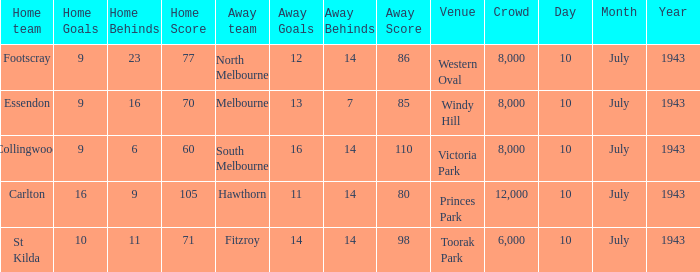When the Away team scored 14.14 (98), which Venue did the game take place? Toorak Park. Would you be able to parse every entry in this table? {'header': ['Home team', 'Home Goals', 'Home Behinds', 'Home Score', 'Away team', 'Away Goals', 'Away Behinds', 'Away Score', 'Venue', 'Crowd', 'Day', 'Month', 'Year'], 'rows': [['Footscray', '9', '23', '77', 'North Melbourne', '12', '14', '86', 'Western Oval', '8,000', '10', 'July', '1943'], ['Essendon', '9', '16', '70', 'Melbourne', '13', '7', '85', 'Windy Hill', '8,000', '10', 'July', '1943'], ['Collingwood', '9', '6', '60', 'South Melbourne', '16', '14', '110', 'Victoria Park', '8,000', '10', 'July', '1943'], ['Carlton', '16', '9', '105', 'Hawthorn', '11', '14', '80', 'Princes Park', '12,000', '10', 'July', '1943'], ['St Kilda', '10', '11', '71', 'Fitzroy', '14', '14', '98', 'Toorak Park', '6,000', '10', 'July', '1943']]} 